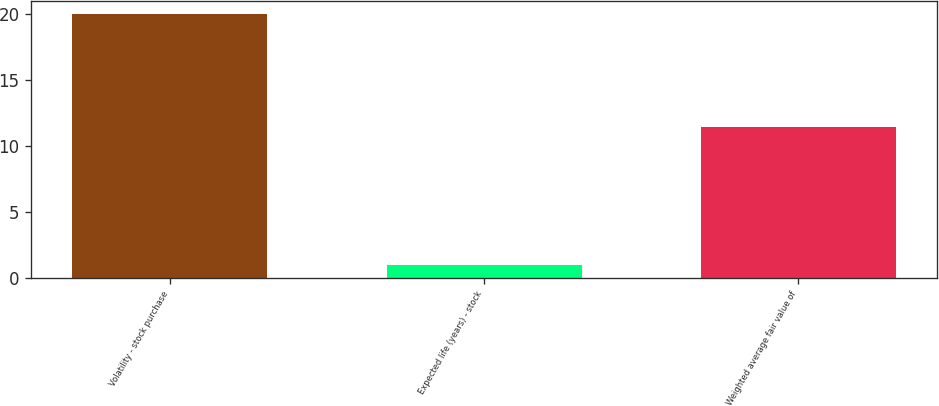Convert chart to OTSL. <chart><loc_0><loc_0><loc_500><loc_500><bar_chart><fcel>Volatility - stock purchase<fcel>Expected life (years) - stock<fcel>Weighted average fair value of<nl><fcel>20<fcel>1<fcel>11.47<nl></chart> 